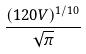Convert formula to latex. <formula><loc_0><loc_0><loc_500><loc_500>\frac { ( 1 2 0 V ) ^ { 1 / 1 0 } } { \sqrt { \pi } }</formula> 